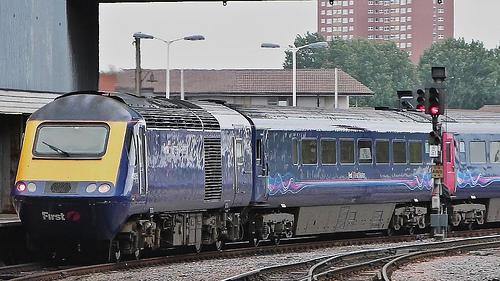Question: where was this photo taken?
Choices:
A. At the bus station.
B. At the subway.
C. At a train station.
D. At the airport.
Answer with the letter. Answer: C Question: when was this photo taken?
Choices:
A. Daytime.
B. Nighttime.
C. Early morning.
D. Midnight.
Answer with the letter. Answer: A Question: what color is the front of the train?
Choices:
A. Yellow.
B. Blue.
C. Green.
D. Red.
Answer with the letter. Answer: A Question: what does it say in the front of the train?
Choices:
A. First.
B. Front.
C. Second.
D. Fourth.
Answer with the letter. Answer: A Question: who is on top of the train?
Choices:
A. Nobody.
B. The lady.
C. A bird.
D. The boy.
Answer with the letter. Answer: A 